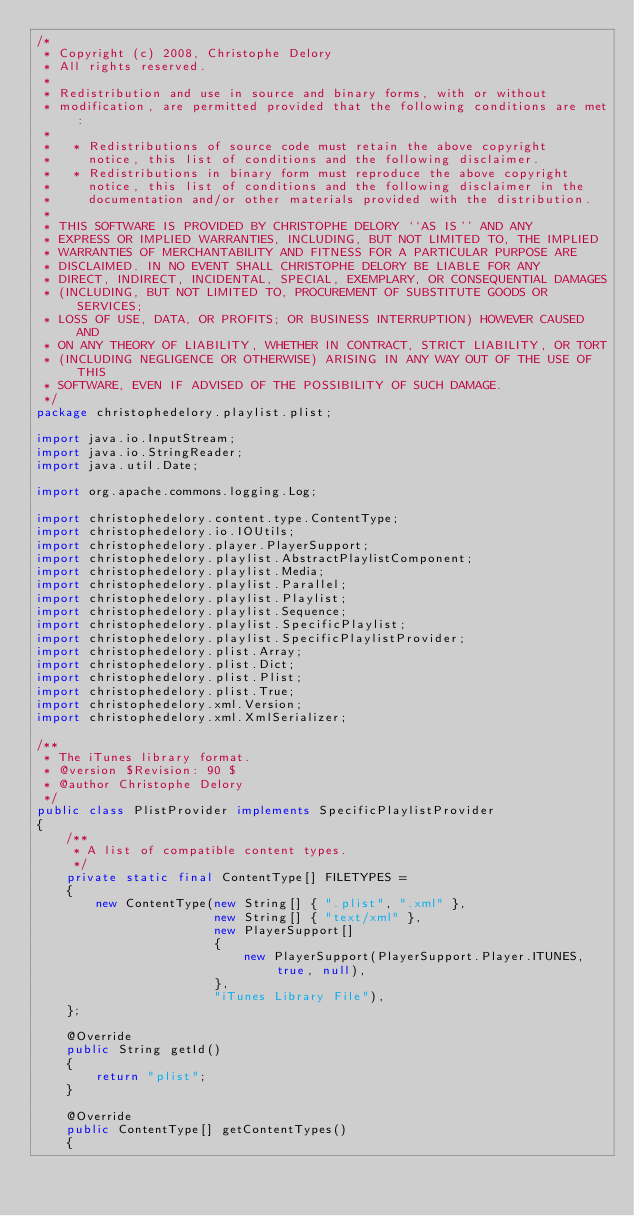<code> <loc_0><loc_0><loc_500><loc_500><_Java_>/*
 * Copyright (c) 2008, Christophe Delory
 * All rights reserved.
 *
 * Redistribution and use in source and binary forms, with or without
 * modification, are permitted provided that the following conditions are met:
 *
 *   * Redistributions of source code must retain the above copyright
 *     notice, this list of conditions and the following disclaimer.
 *   * Redistributions in binary form must reproduce the above copyright
 *     notice, this list of conditions and the following disclaimer in the
 *     documentation and/or other materials provided with the distribution.
 *
 * THIS SOFTWARE IS PROVIDED BY CHRISTOPHE DELORY ``AS IS'' AND ANY
 * EXPRESS OR IMPLIED WARRANTIES, INCLUDING, BUT NOT LIMITED TO, THE IMPLIED
 * WARRANTIES OF MERCHANTABILITY AND FITNESS FOR A PARTICULAR PURPOSE ARE
 * DISCLAIMED. IN NO EVENT SHALL CHRISTOPHE DELORY BE LIABLE FOR ANY
 * DIRECT, INDIRECT, INCIDENTAL, SPECIAL, EXEMPLARY, OR CONSEQUENTIAL DAMAGES
 * (INCLUDING, BUT NOT LIMITED TO, PROCUREMENT OF SUBSTITUTE GOODS OR SERVICES;
 * LOSS OF USE, DATA, OR PROFITS; OR BUSINESS INTERRUPTION) HOWEVER CAUSED AND
 * ON ANY THEORY OF LIABILITY, WHETHER IN CONTRACT, STRICT LIABILITY, OR TORT
 * (INCLUDING NEGLIGENCE OR OTHERWISE) ARISING IN ANY WAY OUT OF THE USE OF THIS
 * SOFTWARE, EVEN IF ADVISED OF THE POSSIBILITY OF SUCH DAMAGE.
 */
package christophedelory.playlist.plist;

import java.io.InputStream;
import java.io.StringReader;
import java.util.Date;

import org.apache.commons.logging.Log;

import christophedelory.content.type.ContentType;
import christophedelory.io.IOUtils;
import christophedelory.player.PlayerSupport;
import christophedelory.playlist.AbstractPlaylistComponent;
import christophedelory.playlist.Media;
import christophedelory.playlist.Parallel;
import christophedelory.playlist.Playlist;
import christophedelory.playlist.Sequence;
import christophedelory.playlist.SpecificPlaylist;
import christophedelory.playlist.SpecificPlaylistProvider;
import christophedelory.plist.Array;
import christophedelory.plist.Dict;
import christophedelory.plist.Plist;
import christophedelory.plist.True;
import christophedelory.xml.Version;
import christophedelory.xml.XmlSerializer;

/**
 * The iTunes library format.
 * @version $Revision: 90 $
 * @author Christophe Delory
 */
public class PlistProvider implements SpecificPlaylistProvider
{
    /**
     * A list of compatible content types.
     */
    private static final ContentType[] FILETYPES =
    {
        new ContentType(new String[] { ".plist", ".xml" },
                        new String[] { "text/xml" },
                        new PlayerSupport[]
                        {
                            new PlayerSupport(PlayerSupport.Player.ITUNES, true, null),
                        },
                        "iTunes Library File"),
    };

    @Override
    public String getId()
    {
        return "plist";
    }

    @Override
    public ContentType[] getContentTypes()
    {</code> 